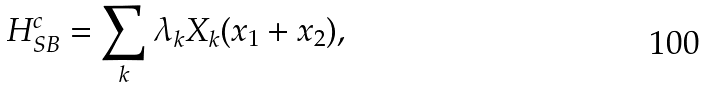<formula> <loc_0><loc_0><loc_500><loc_500>H _ { S B } ^ { c } = \sum _ { k } \lambda _ { k } X _ { k } ( x _ { 1 } + x _ { 2 } ) ,</formula> 